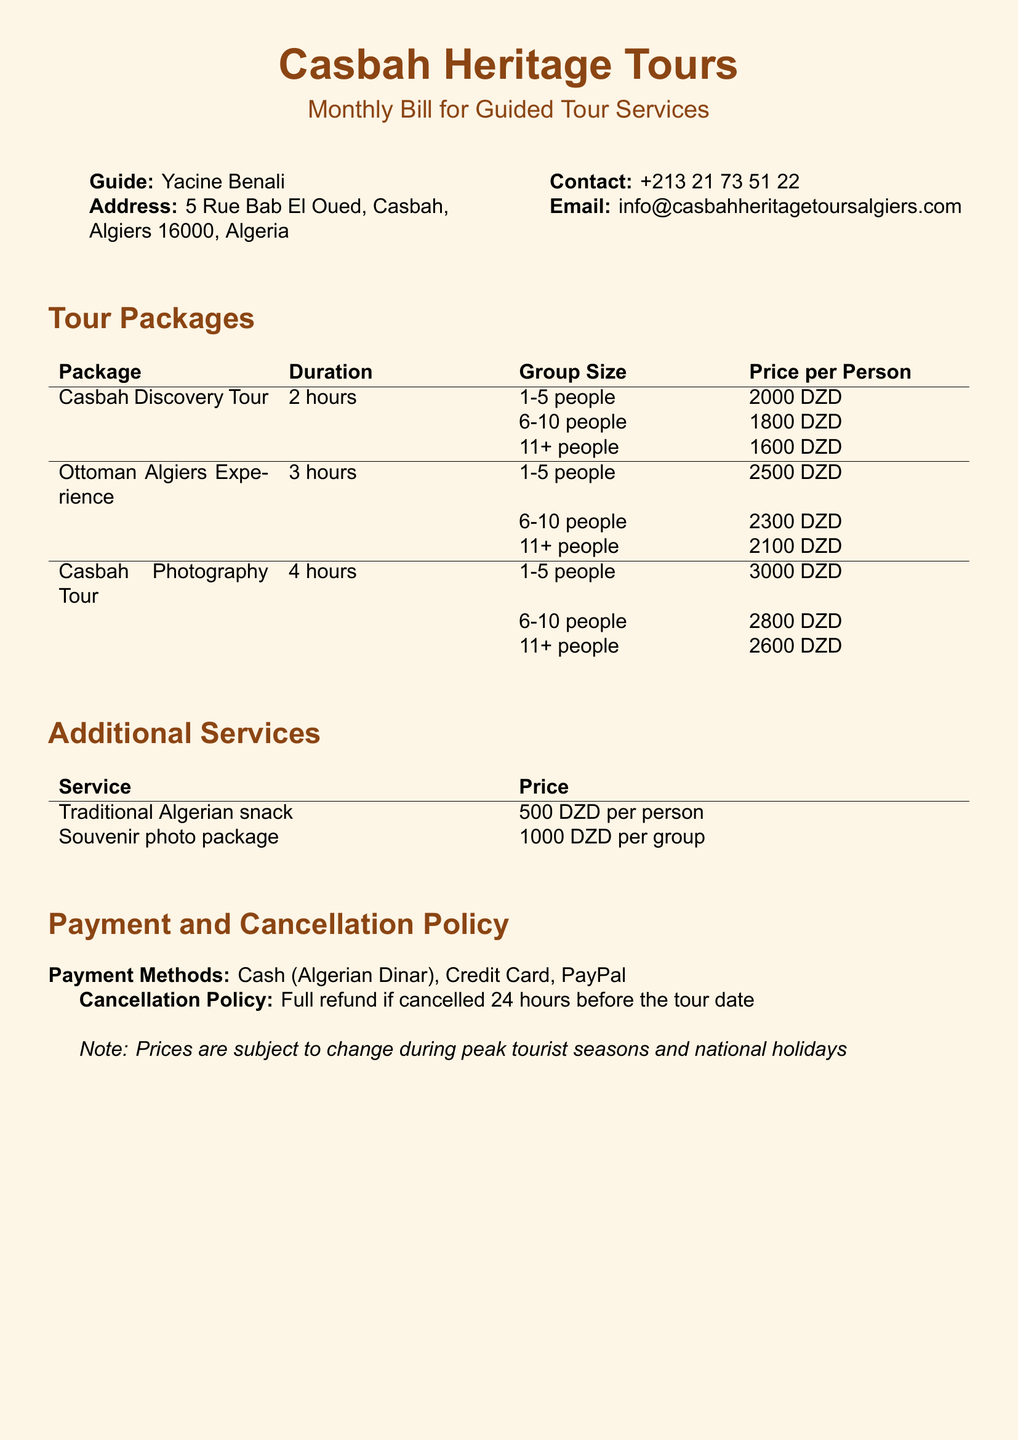What is the name of the guide? The guide's name is stated in the document as the individual responsible for the tours.
Answer: Yacine Benali What is the price per person for a Casbah Discovery Tour for a group of 6-10 people? The document specifies the pricing for this particular group size under the Casbah Discovery Tour section.
Answer: 1800 DZD How long is the Ottoman Algiers Experience tour? The duration of the tour is mentioned next to the package name to indicate how long it lasts.
Answer: 3 hours What is the cancellation policy stated in the document? The cancellation policy details the terms under which a customer can receive a refund.
Answer: Full refund if cancelled 24 hours before the tour date How much does a traditional Algerian snack cost per person? This information is found in the Additional Services section regarding snacks offered during tours.
Answer: 500 DZD per person What is the maximum group size for the Casbah Photography Tour? The document defines group sizes for various package tours, indicating the maximum number for this specific tour.
Answer: 11+ people What additional service costs 1000 DZD? This service is specifically highlighted in the Additional Services section with its corresponding price.
Answer: Souvenir photo package What payment methods are accepted? The document specifies available payment options for customers wishing to pay for the tour services.
Answer: Cash, Credit Card, PayPal What color is used for the document's background? The background color is described in the style settings, indicating the overall look of the document.
Answer: Sandbg 